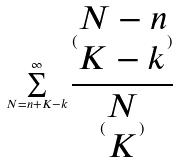<formula> <loc_0><loc_0><loc_500><loc_500>\sum _ { N = n + K - k } ^ { \infty } \frac { ( \begin{matrix} N - n \\ K - k \end{matrix} ) } { ( \begin{matrix} N \\ K \end{matrix} ) }</formula> 